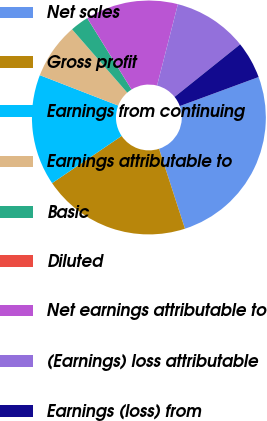<chart> <loc_0><loc_0><loc_500><loc_500><pie_chart><fcel>Net sales<fcel>Gross profit<fcel>Earnings from continuing<fcel>Earnings attributable to<fcel>Basic<fcel>Diluted<fcel>Net earnings attributable to<fcel>(Earnings) loss attributable<fcel>Earnings (loss) from<nl><fcel>25.63%<fcel>20.5%<fcel>15.38%<fcel>7.7%<fcel>2.57%<fcel>0.01%<fcel>12.82%<fcel>10.26%<fcel>5.13%<nl></chart> 